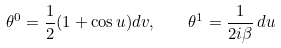<formula> <loc_0><loc_0><loc_500><loc_500>\theta ^ { 0 } = \frac { 1 } { 2 } ( 1 + \cos u ) d v , \quad \theta ^ { 1 } = \frac { 1 } { 2 i \beta } \, d u</formula> 